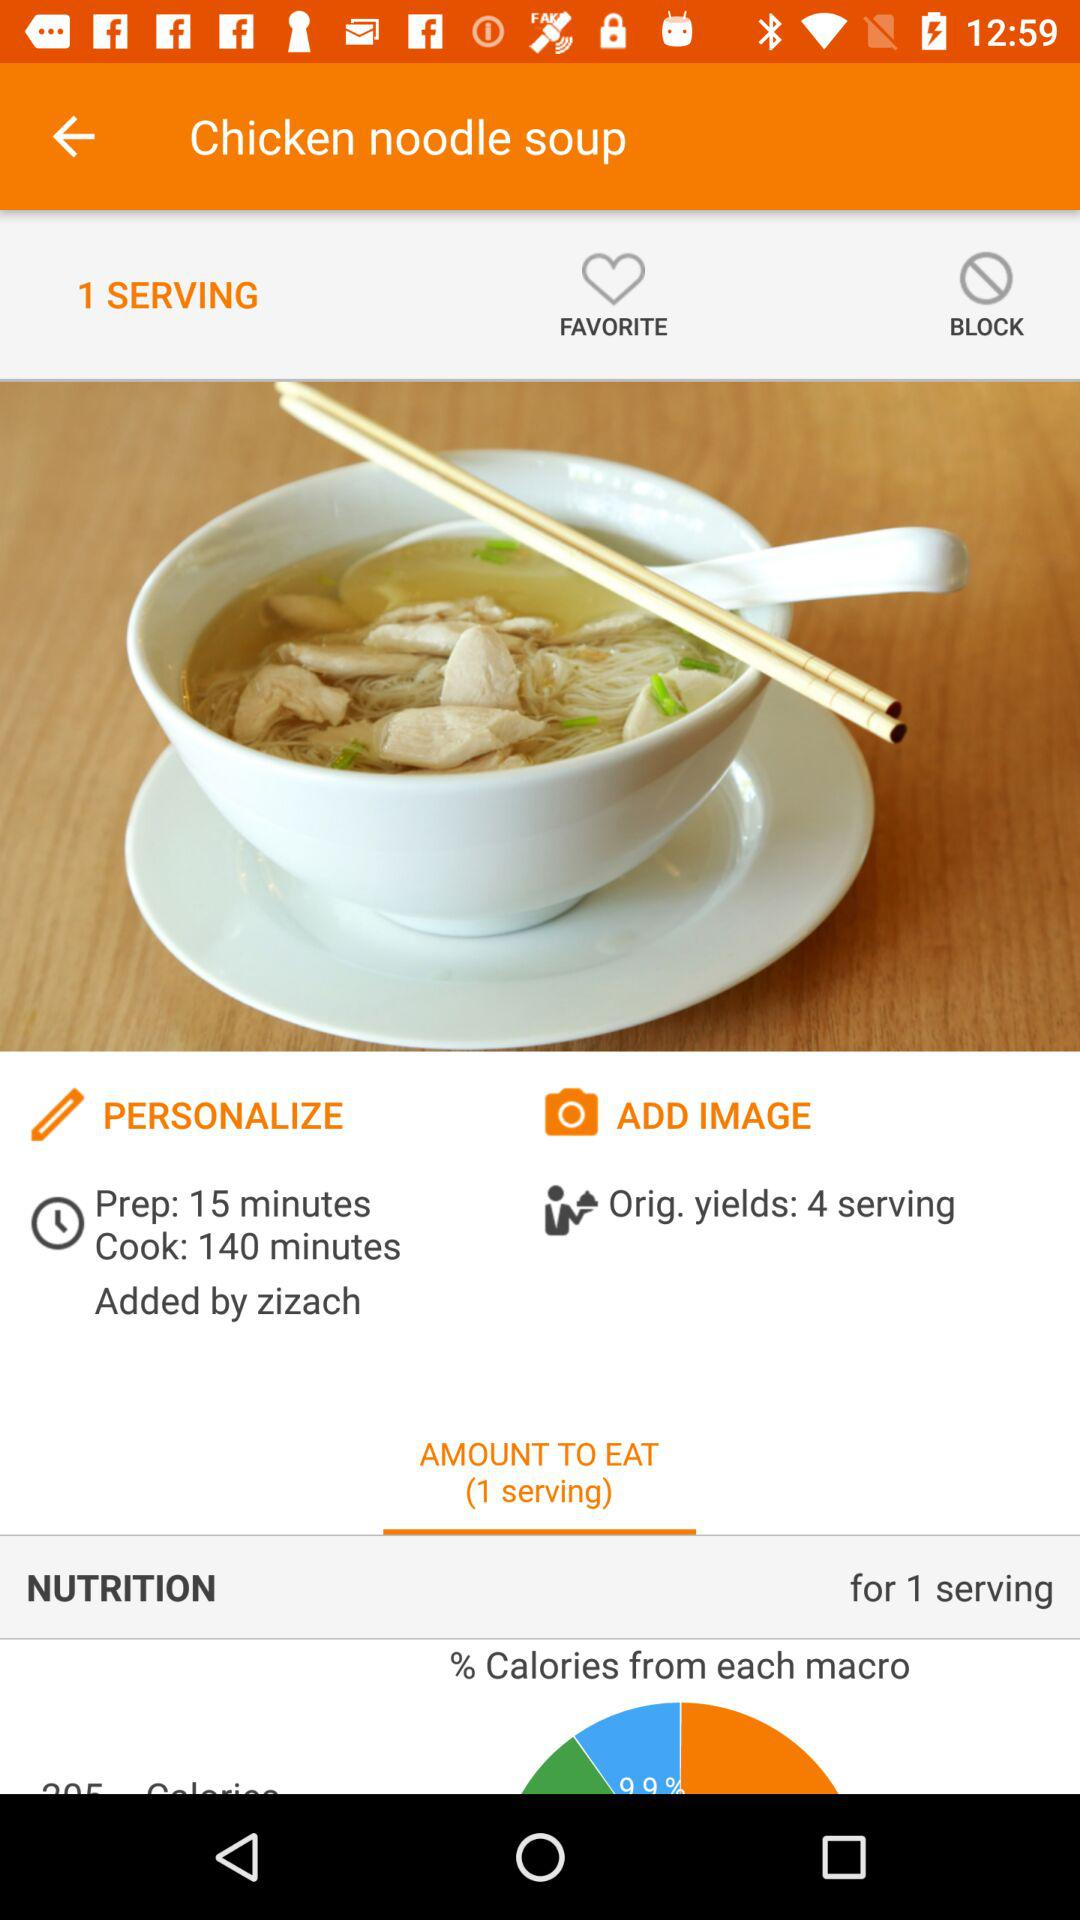What is the name of the recipe? The name of the recipe is "Chicken noodle soup". 